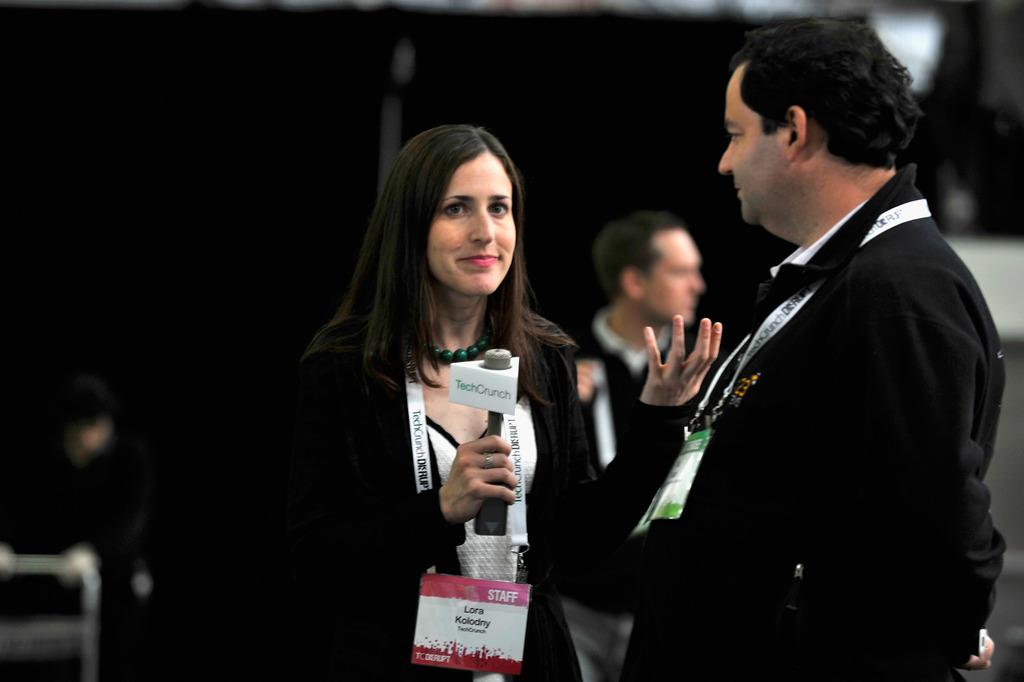Who is the main subject in the image? There is a woman in the image. What is the woman wearing? The woman is wearing a tag. What is the woman holding? The woman is holding a microphone. Can you describe the man in the image? There is a man standing behind the woman. What type of beef is the woman reading about in the image? There is no beef or reading material present in the image. 